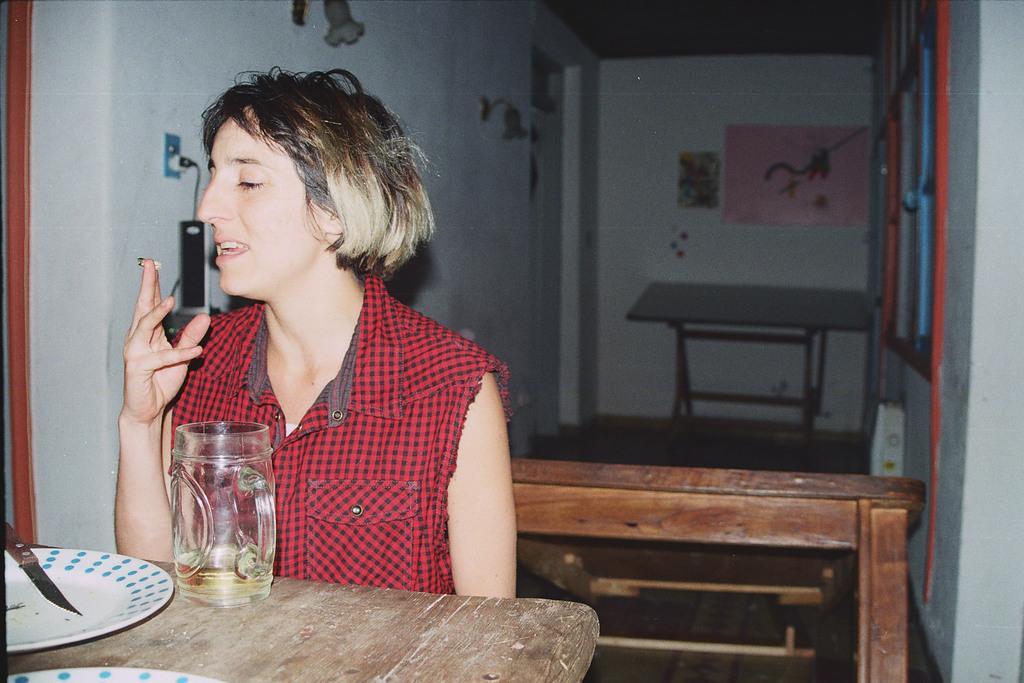Describe this image in one or two sentences. In this image we can see a woman on the left side and she is holding an object in her fingers. There are plates, knife, liquid in a glass on the table. In the background there are objects, tables, lights and papers on the wall. 